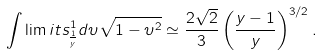<formula> <loc_0><loc_0><loc_500><loc_500>\int \lim i t s _ { \frac { 1 } { y } } ^ { 1 } d \upsilon \sqrt { 1 - \upsilon ^ { 2 } } \simeq \frac { 2 \sqrt { 2 } } { 3 } \left ( \frac { y - 1 } { y } \right ) ^ { 3 / 2 } .</formula> 